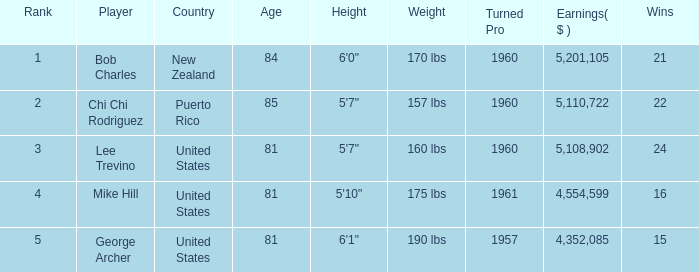What is the lowest level of Earnings($) to have a Wins value of 22 and a Rank lower than 2? None. 